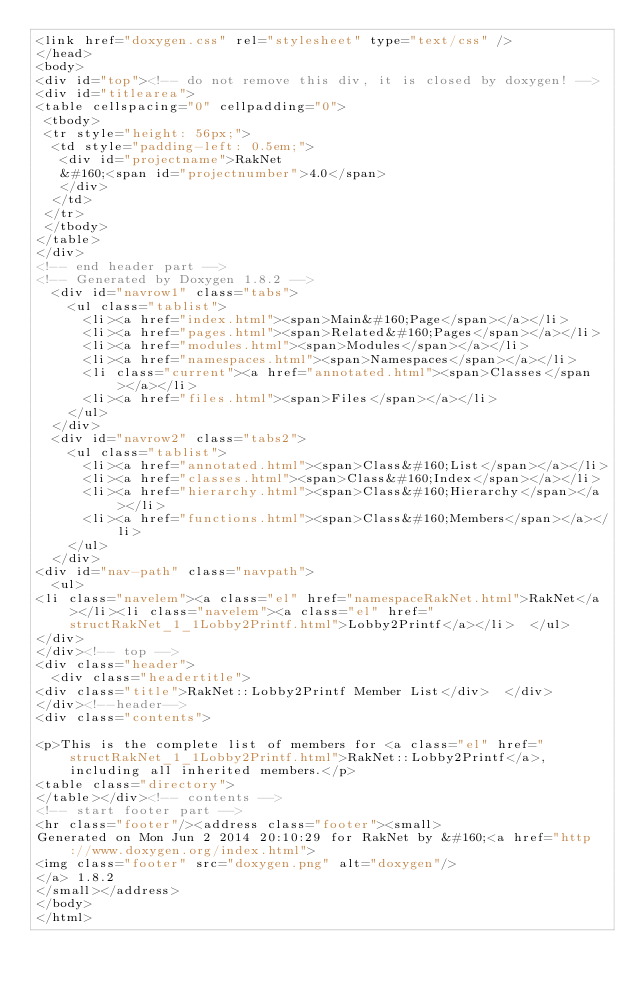Convert code to text. <code><loc_0><loc_0><loc_500><loc_500><_HTML_><link href="doxygen.css" rel="stylesheet" type="text/css" />
</head>
<body>
<div id="top"><!-- do not remove this div, it is closed by doxygen! -->
<div id="titlearea">
<table cellspacing="0" cellpadding="0">
 <tbody>
 <tr style="height: 56px;">
  <td style="padding-left: 0.5em;">
   <div id="projectname">RakNet
   &#160;<span id="projectnumber">4.0</span>
   </div>
  </td>
 </tr>
 </tbody>
</table>
</div>
<!-- end header part -->
<!-- Generated by Doxygen 1.8.2 -->
  <div id="navrow1" class="tabs">
    <ul class="tablist">
      <li><a href="index.html"><span>Main&#160;Page</span></a></li>
      <li><a href="pages.html"><span>Related&#160;Pages</span></a></li>
      <li><a href="modules.html"><span>Modules</span></a></li>
      <li><a href="namespaces.html"><span>Namespaces</span></a></li>
      <li class="current"><a href="annotated.html"><span>Classes</span></a></li>
      <li><a href="files.html"><span>Files</span></a></li>
    </ul>
  </div>
  <div id="navrow2" class="tabs2">
    <ul class="tablist">
      <li><a href="annotated.html"><span>Class&#160;List</span></a></li>
      <li><a href="classes.html"><span>Class&#160;Index</span></a></li>
      <li><a href="hierarchy.html"><span>Class&#160;Hierarchy</span></a></li>
      <li><a href="functions.html"><span>Class&#160;Members</span></a></li>
    </ul>
  </div>
<div id="nav-path" class="navpath">
  <ul>
<li class="navelem"><a class="el" href="namespaceRakNet.html">RakNet</a></li><li class="navelem"><a class="el" href="structRakNet_1_1Lobby2Printf.html">Lobby2Printf</a></li>  </ul>
</div>
</div><!-- top -->
<div class="header">
  <div class="headertitle">
<div class="title">RakNet::Lobby2Printf Member List</div>  </div>
</div><!--header-->
<div class="contents">

<p>This is the complete list of members for <a class="el" href="structRakNet_1_1Lobby2Printf.html">RakNet::Lobby2Printf</a>, including all inherited members.</p>
<table class="directory">
</table></div><!-- contents -->
<!-- start footer part -->
<hr class="footer"/><address class="footer"><small>
Generated on Mon Jun 2 2014 20:10:29 for RakNet by &#160;<a href="http://www.doxygen.org/index.html">
<img class="footer" src="doxygen.png" alt="doxygen"/>
</a> 1.8.2
</small></address>
</body>
</html>
</code> 